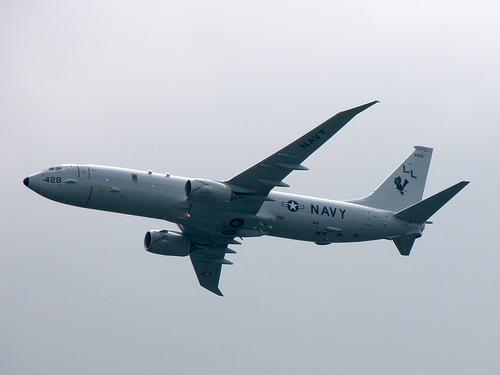Question: where are the numbers 428?
Choices:
A. On the plane.
B. Near wing.
C. By the windows.
D. Nose of plane.
Answer with the letter. Answer: D Question: what is in the sky?
Choices:
A. Plane.
B. Birds.
C. Clouds.
D. People.
Answer with the letter. Answer: A Question: where is the plane?
Choices:
A. Sky.
B. Runway.
C. Airport.
D. Flying.
Answer with the letter. Answer: A Question: what color is the plane?
Choices:
A. Gold.
B. White.
C. Silver.
D. Black.
Answer with the letter. Answer: C Question: what branch of the military owns this plane?
Choices:
A. Army.
B. Navy.
C. Marines.
D. Air force.
Answer with the letter. Answer: B 